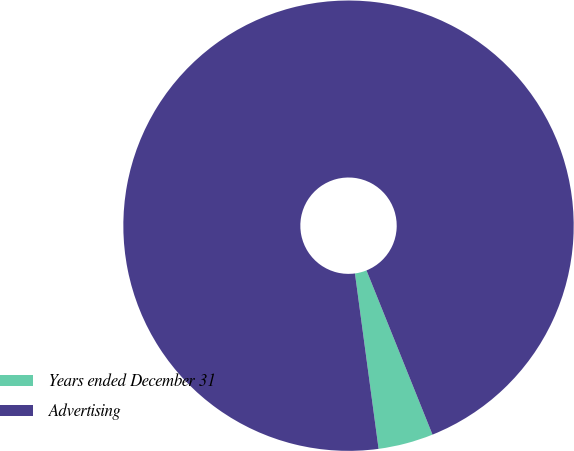Convert chart. <chart><loc_0><loc_0><loc_500><loc_500><pie_chart><fcel>Years ended December 31<fcel>Advertising<nl><fcel>3.95%<fcel>96.05%<nl></chart> 